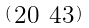<formula> <loc_0><loc_0><loc_500><loc_500>\begin{psmallmatrix} 2 0 & 4 3 \end{psmallmatrix}</formula> 